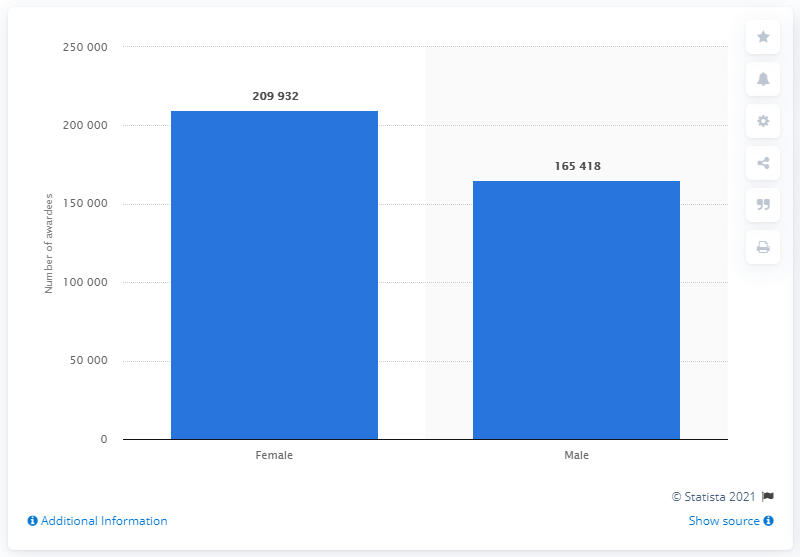How many female students were awarded their undergraduate degree in Karnataka in 2019?
 209932 